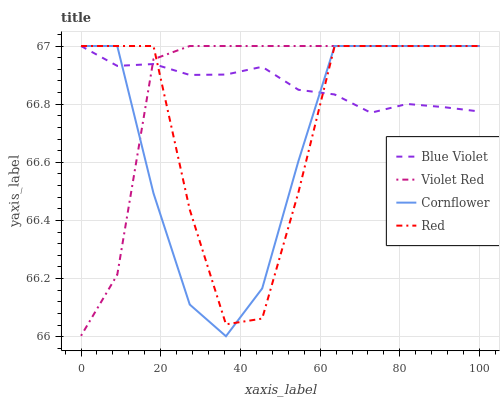Does Red have the minimum area under the curve?
Answer yes or no. No. Does Red have the maximum area under the curve?
Answer yes or no. No. Is Violet Red the smoothest?
Answer yes or no. No. Is Violet Red the roughest?
Answer yes or no. No. Does Violet Red have the lowest value?
Answer yes or no. No. 